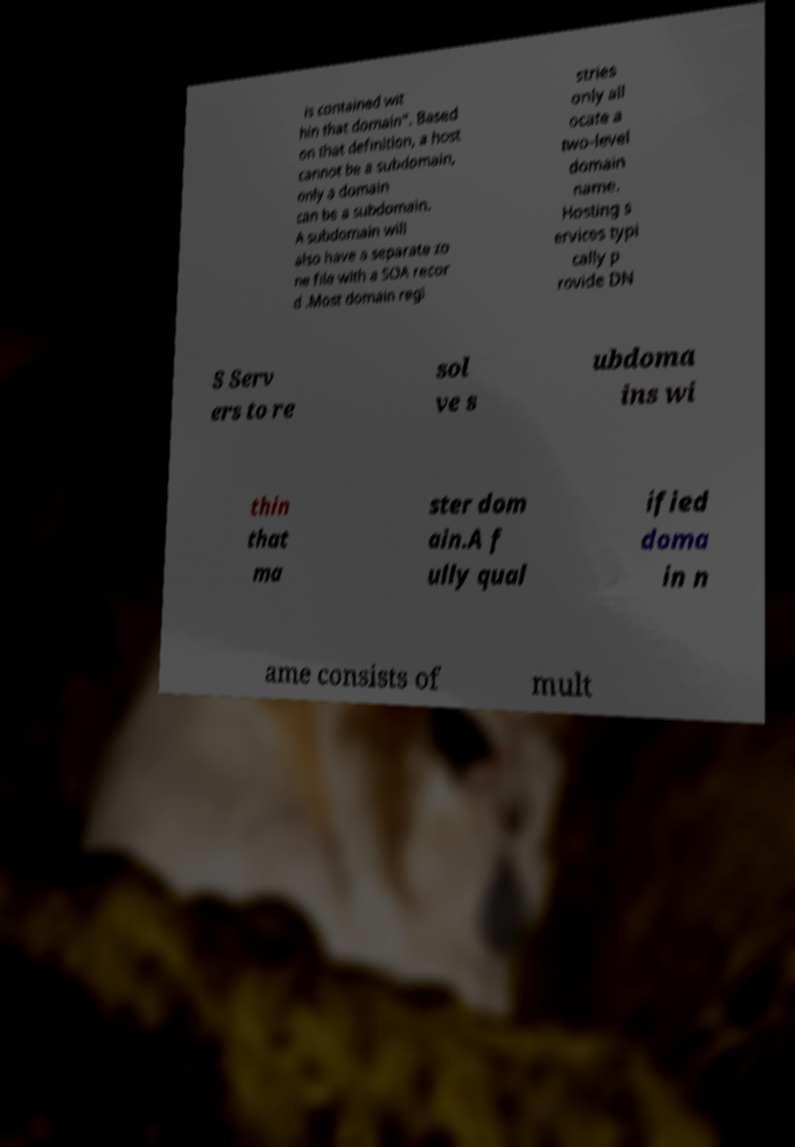Could you assist in decoding the text presented in this image and type it out clearly? is contained wit hin that domain". Based on that definition, a host cannot be a subdomain, only a domain can be a subdomain. A subdomain will also have a separate zo ne file with a SOA recor d .Most domain regi stries only all ocate a two-level domain name. Hosting s ervices typi cally p rovide DN S Serv ers to re sol ve s ubdoma ins wi thin that ma ster dom ain.A f ully qual ified doma in n ame consists of mult 